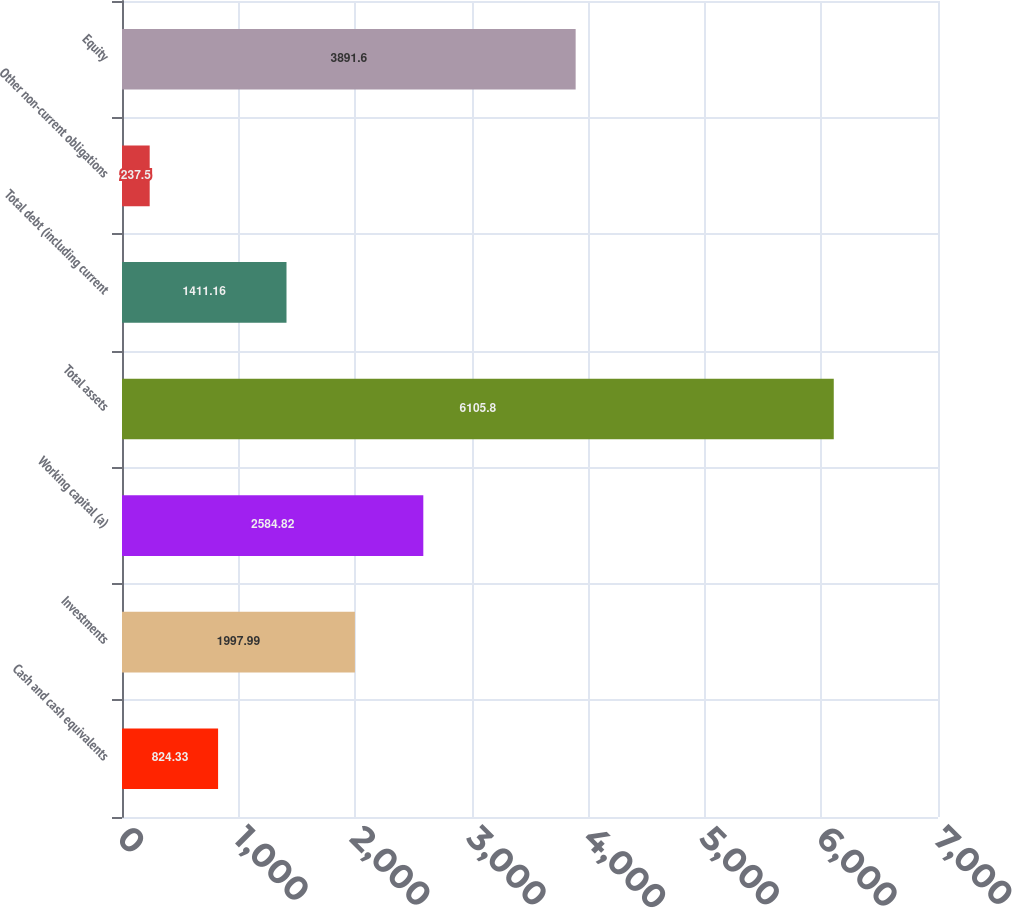Convert chart. <chart><loc_0><loc_0><loc_500><loc_500><bar_chart><fcel>Cash and cash equivalents<fcel>Investments<fcel>Working capital (a)<fcel>Total assets<fcel>Total debt (including current<fcel>Other non-current obligations<fcel>Equity<nl><fcel>824.33<fcel>1997.99<fcel>2584.82<fcel>6105.8<fcel>1411.16<fcel>237.5<fcel>3891.6<nl></chart> 